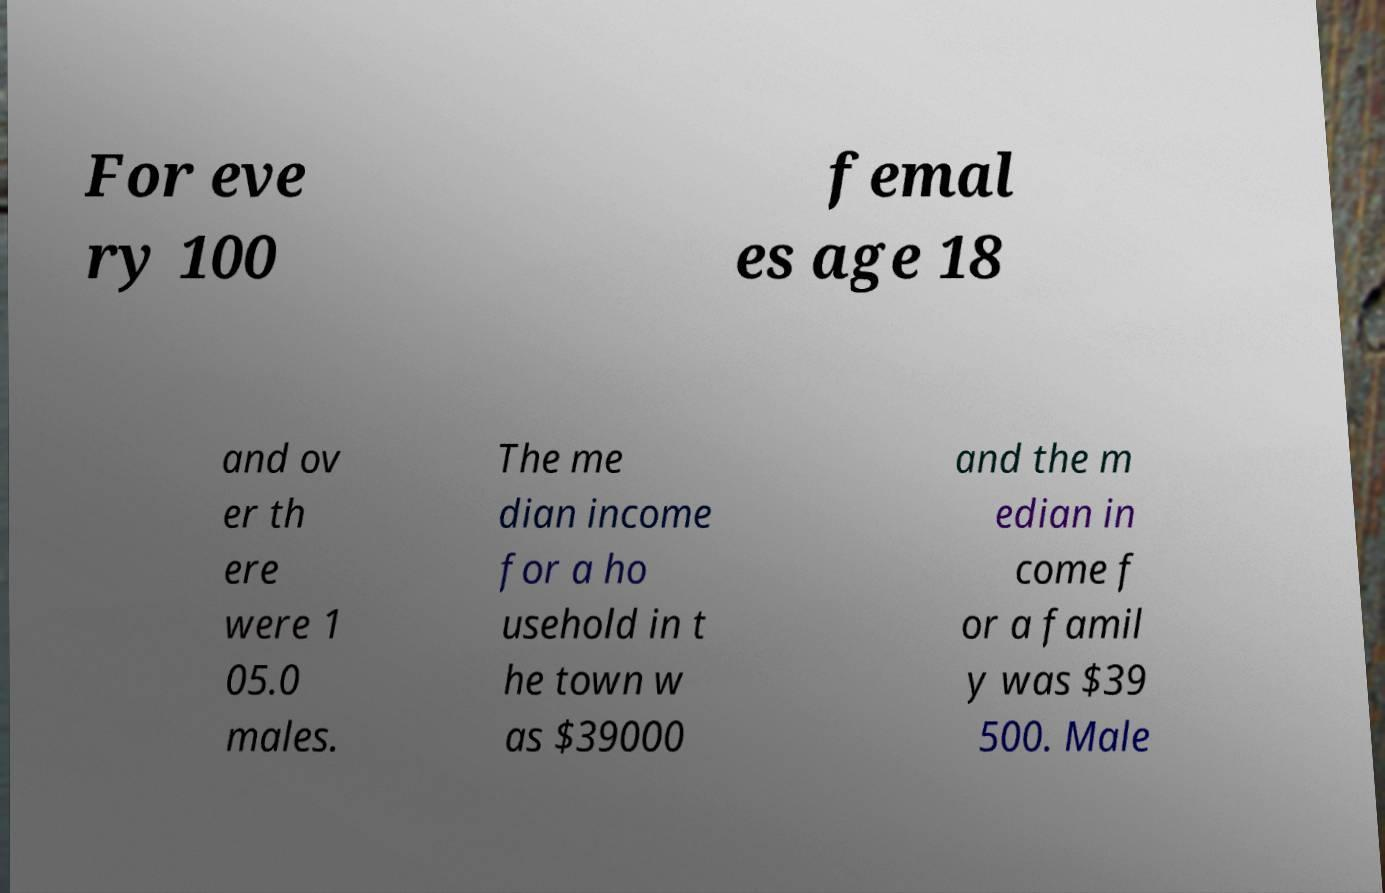For documentation purposes, I need the text within this image transcribed. Could you provide that? For eve ry 100 femal es age 18 and ov er th ere were 1 05.0 males. The me dian income for a ho usehold in t he town w as $39000 and the m edian in come f or a famil y was $39 500. Male 